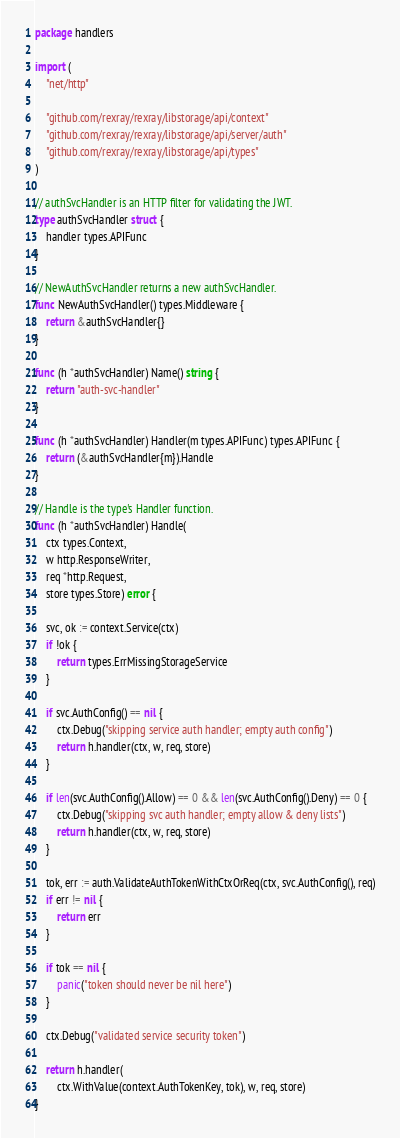<code> <loc_0><loc_0><loc_500><loc_500><_Go_>package handlers

import (
	"net/http"

	"github.com/rexray/rexray/libstorage/api/context"
	"github.com/rexray/rexray/libstorage/api/server/auth"
	"github.com/rexray/rexray/libstorage/api/types"
)

// authSvcHandler is an HTTP filter for validating the JWT.
type authSvcHandler struct {
	handler types.APIFunc
}

// NewAuthSvcHandler returns a new authSvcHandler.
func NewAuthSvcHandler() types.Middleware {
	return &authSvcHandler{}
}

func (h *authSvcHandler) Name() string {
	return "auth-svc-handler"
}

func (h *authSvcHandler) Handler(m types.APIFunc) types.APIFunc {
	return (&authSvcHandler{m}).Handle
}

// Handle is the type's Handler function.
func (h *authSvcHandler) Handle(
	ctx types.Context,
	w http.ResponseWriter,
	req *http.Request,
	store types.Store) error {

	svc, ok := context.Service(ctx)
	if !ok {
		return types.ErrMissingStorageService
	}

	if svc.AuthConfig() == nil {
		ctx.Debug("skipping service auth handler; empty auth config")
		return h.handler(ctx, w, req, store)
	}

	if len(svc.AuthConfig().Allow) == 0 && len(svc.AuthConfig().Deny) == 0 {
		ctx.Debug("skipping svc auth handler; empty allow & deny lists")
		return h.handler(ctx, w, req, store)
	}

	tok, err := auth.ValidateAuthTokenWithCtxOrReq(ctx, svc.AuthConfig(), req)
	if err != nil {
		return err
	}

	if tok == nil {
		panic("token should never be nil here")
	}

	ctx.Debug("validated service security token")

	return h.handler(
		ctx.WithValue(context.AuthTokenKey, tok), w, req, store)
}
</code> 